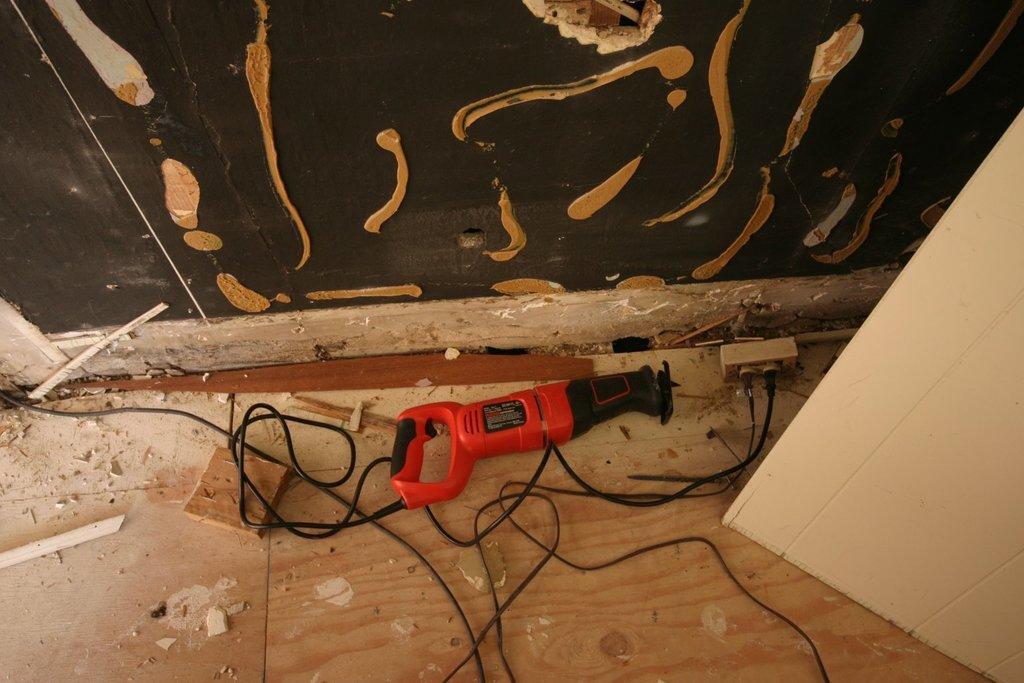Could you give a brief overview of what you see in this image? In the foreground of the image we can see a machine, wire and switchboard. On the top of the image we can see cardboard. On the right side of the image we can see a car board. 